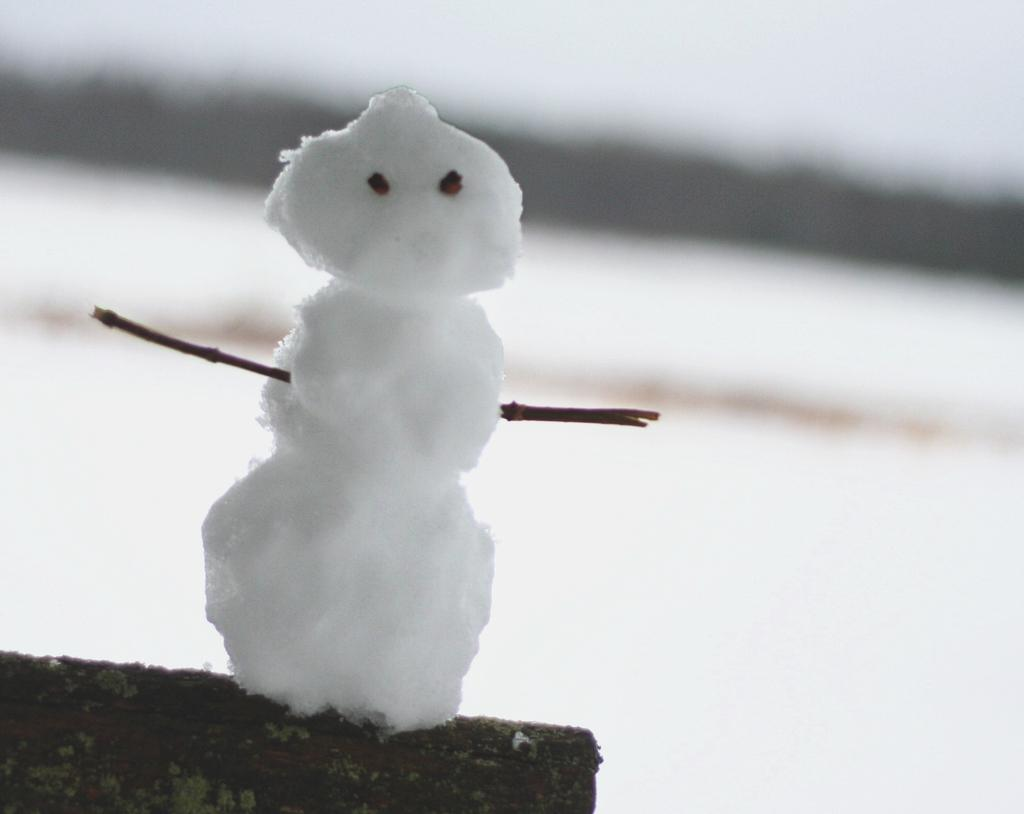What is the main subject in the image? There is a snowman in the image. Can you describe the background of the image? The background of the image is blurred. What type of garden can be seen in the image? There is no garden present in the image. What type of care is being provided to the snowman in the image? The image does not show any care being provided to the snowman. 